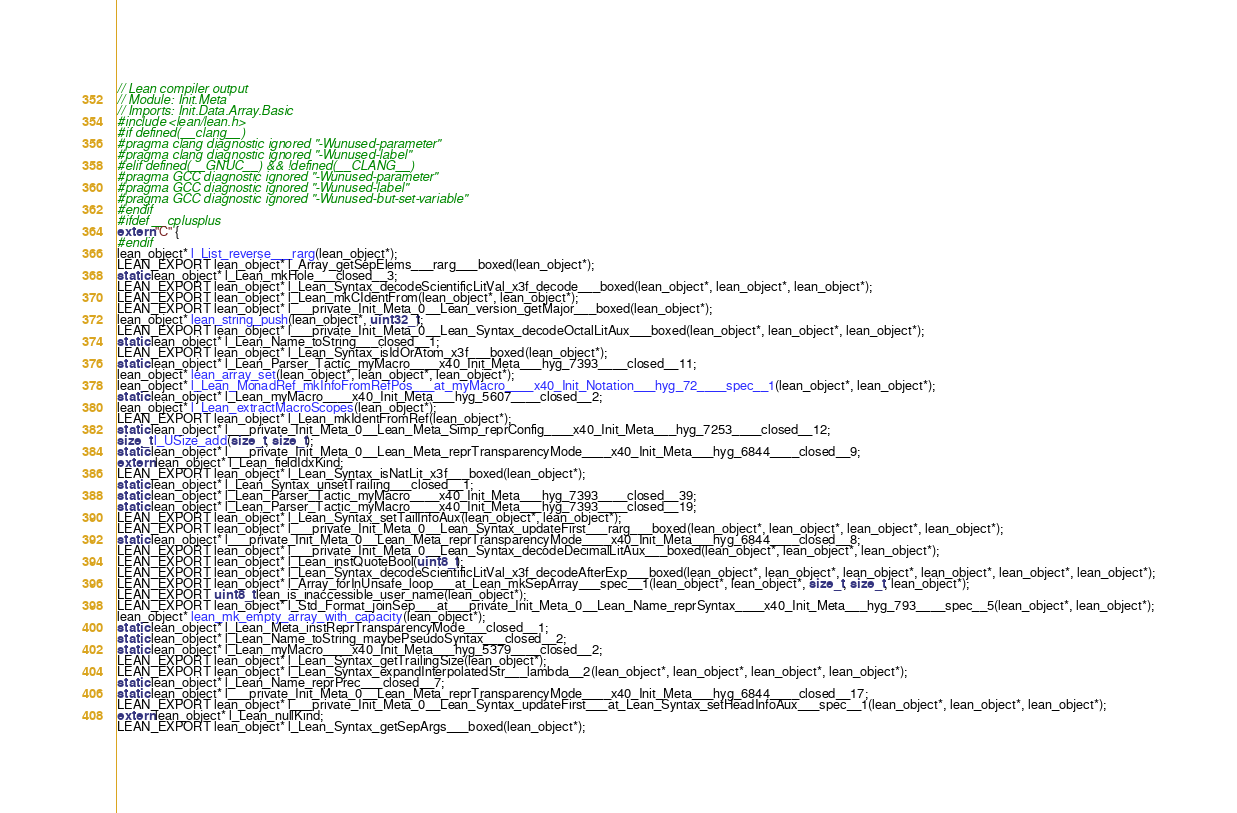Convert code to text. <code><loc_0><loc_0><loc_500><loc_500><_C_>// Lean compiler output
// Module: Init.Meta
// Imports: Init.Data.Array.Basic
#include <lean/lean.h>
#if defined(__clang__)
#pragma clang diagnostic ignored "-Wunused-parameter"
#pragma clang diagnostic ignored "-Wunused-label"
#elif defined(__GNUC__) && !defined(__CLANG__)
#pragma GCC diagnostic ignored "-Wunused-parameter"
#pragma GCC diagnostic ignored "-Wunused-label"
#pragma GCC diagnostic ignored "-Wunused-but-set-variable"
#endif
#ifdef __cplusplus
extern "C" {
#endif
lean_object* l_List_reverse___rarg(lean_object*);
LEAN_EXPORT lean_object* l_Array_getSepElems___rarg___boxed(lean_object*);
static lean_object* l_Lean_mkHole___closed__3;
LEAN_EXPORT lean_object* l_Lean_Syntax_decodeScientificLitVal_x3f_decode___boxed(lean_object*, lean_object*, lean_object*);
LEAN_EXPORT lean_object* l_Lean_mkCIdentFrom(lean_object*, lean_object*);
LEAN_EXPORT lean_object* l___private_Init_Meta_0__Lean_version_getMajor___boxed(lean_object*);
lean_object* lean_string_push(lean_object*, uint32_t);
LEAN_EXPORT lean_object* l___private_Init_Meta_0__Lean_Syntax_decodeOctalLitAux___boxed(lean_object*, lean_object*, lean_object*);
static lean_object* l_Lean_Name_toString___closed__1;
LEAN_EXPORT lean_object* l_Lean_Syntax_isIdOrAtom_x3f___boxed(lean_object*);
static lean_object* l_Lean_Parser_Tactic_myMacro____x40_Init_Meta___hyg_7393____closed__11;
lean_object* lean_array_set(lean_object*, lean_object*, lean_object*);
lean_object* l_Lean_MonadRef_mkInfoFromRefPos___at_myMacro____x40_Init_Notation___hyg_72____spec__1(lean_object*, lean_object*);
static lean_object* l_Lean_myMacro____x40_Init_Meta___hyg_5607____closed__2;
lean_object* l_Lean_extractMacroScopes(lean_object*);
LEAN_EXPORT lean_object* l_Lean_mkIdentFromRef(lean_object*);
static lean_object* l___private_Init_Meta_0__Lean_Meta_Simp_reprConfig____x40_Init_Meta___hyg_7253____closed__12;
size_t l_USize_add(size_t, size_t);
static lean_object* l___private_Init_Meta_0__Lean_Meta_reprTransparencyMode____x40_Init_Meta___hyg_6844____closed__9;
extern lean_object* l_Lean_fieldIdxKind;
LEAN_EXPORT lean_object* l_Lean_Syntax_isNatLit_x3f___boxed(lean_object*);
static lean_object* l_Lean_Syntax_unsetTrailing___closed__1;
static lean_object* l_Lean_Parser_Tactic_myMacro____x40_Init_Meta___hyg_7393____closed__39;
static lean_object* l_Lean_Parser_Tactic_myMacro____x40_Init_Meta___hyg_7393____closed__19;
LEAN_EXPORT lean_object* l_Lean_Syntax_setTailInfoAux(lean_object*, lean_object*);
LEAN_EXPORT lean_object* l___private_Init_Meta_0__Lean_Syntax_updateFirst___rarg___boxed(lean_object*, lean_object*, lean_object*, lean_object*);
static lean_object* l___private_Init_Meta_0__Lean_Meta_reprTransparencyMode____x40_Init_Meta___hyg_6844____closed__8;
LEAN_EXPORT lean_object* l___private_Init_Meta_0__Lean_Syntax_decodeDecimalLitAux___boxed(lean_object*, lean_object*, lean_object*);
LEAN_EXPORT lean_object* l_Lean_instQuoteBool(uint8_t);
LEAN_EXPORT lean_object* l_Lean_Syntax_decodeScientificLitVal_x3f_decodeAfterExp___boxed(lean_object*, lean_object*, lean_object*, lean_object*, lean_object*, lean_object*);
LEAN_EXPORT lean_object* l_Array_forInUnsafe_loop___at_Lean_mkSepArray___spec__1(lean_object*, lean_object*, size_t, size_t, lean_object*);
LEAN_EXPORT uint8_t lean_is_inaccessible_user_name(lean_object*);
LEAN_EXPORT lean_object* l_Std_Format_joinSep___at___private_Init_Meta_0__Lean_Name_reprSyntax____x40_Init_Meta___hyg_793____spec__5(lean_object*, lean_object*);
lean_object* lean_mk_empty_array_with_capacity(lean_object*);
static lean_object* l_Lean_Meta_instReprTransparencyMode___closed__1;
static lean_object* l_Lean_Name_toString_maybePseudoSyntax___closed__2;
static lean_object* l_Lean_myMacro____x40_Init_Meta___hyg_5379____closed__2;
LEAN_EXPORT lean_object* l_Lean_Syntax_getTrailingSize(lean_object*);
LEAN_EXPORT lean_object* l_Lean_Syntax_expandInterpolatedStr___lambda__2(lean_object*, lean_object*, lean_object*, lean_object*);
static lean_object* l_Lean_Name_reprPrec___closed__7;
static lean_object* l___private_Init_Meta_0__Lean_Meta_reprTransparencyMode____x40_Init_Meta___hyg_6844____closed__17;
LEAN_EXPORT lean_object* l___private_Init_Meta_0__Lean_Syntax_updateFirst___at_Lean_Syntax_setHeadInfoAux___spec__1(lean_object*, lean_object*, lean_object*);
extern lean_object* l_Lean_nullKind;
LEAN_EXPORT lean_object* l_Lean_Syntax_getSepArgs___boxed(lean_object*);</code> 